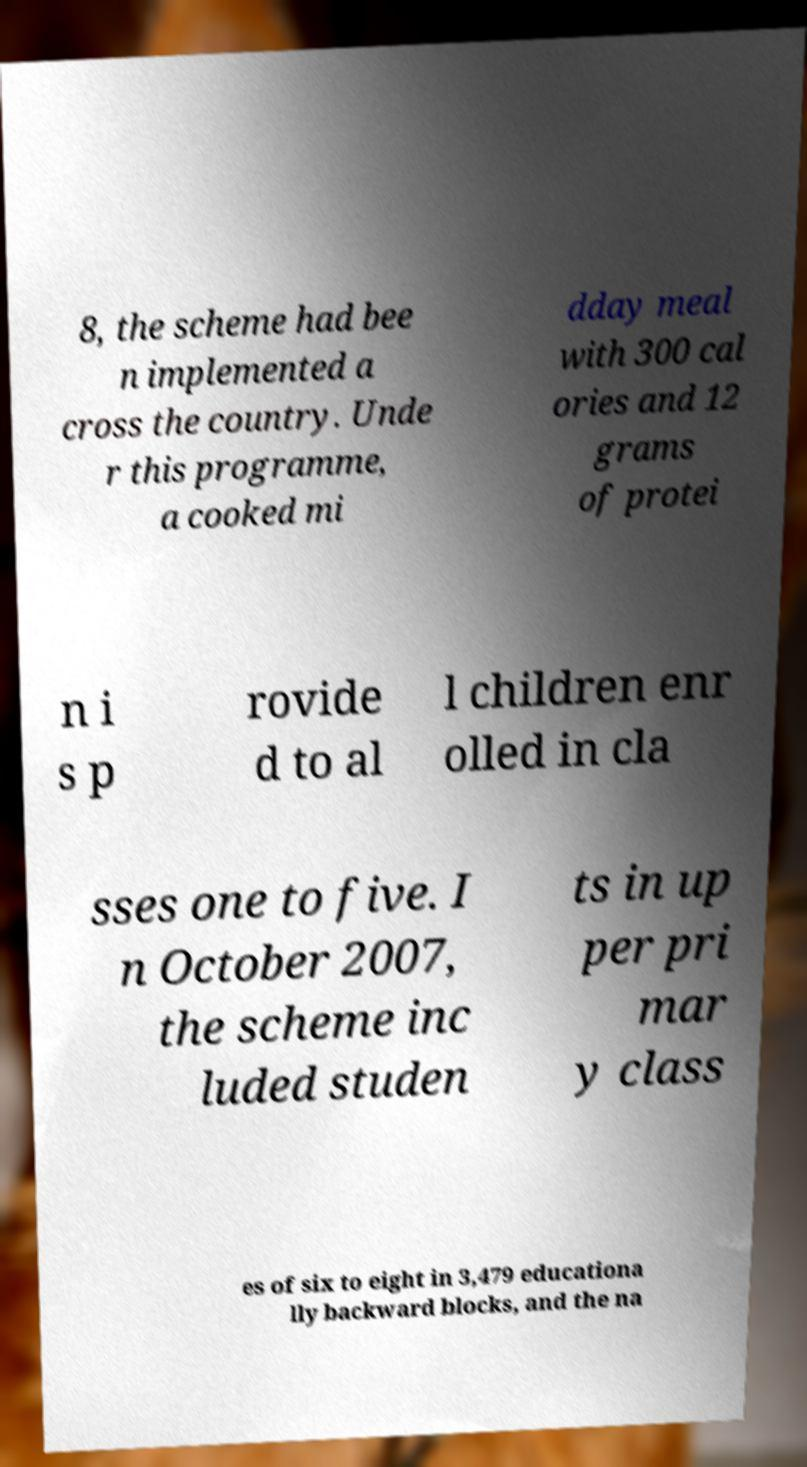For documentation purposes, I need the text within this image transcribed. Could you provide that? 8, the scheme had bee n implemented a cross the country. Unde r this programme, a cooked mi dday meal with 300 cal ories and 12 grams of protei n i s p rovide d to al l children enr olled in cla sses one to five. I n October 2007, the scheme inc luded studen ts in up per pri mar y class es of six to eight in 3,479 educationa lly backward blocks, and the na 